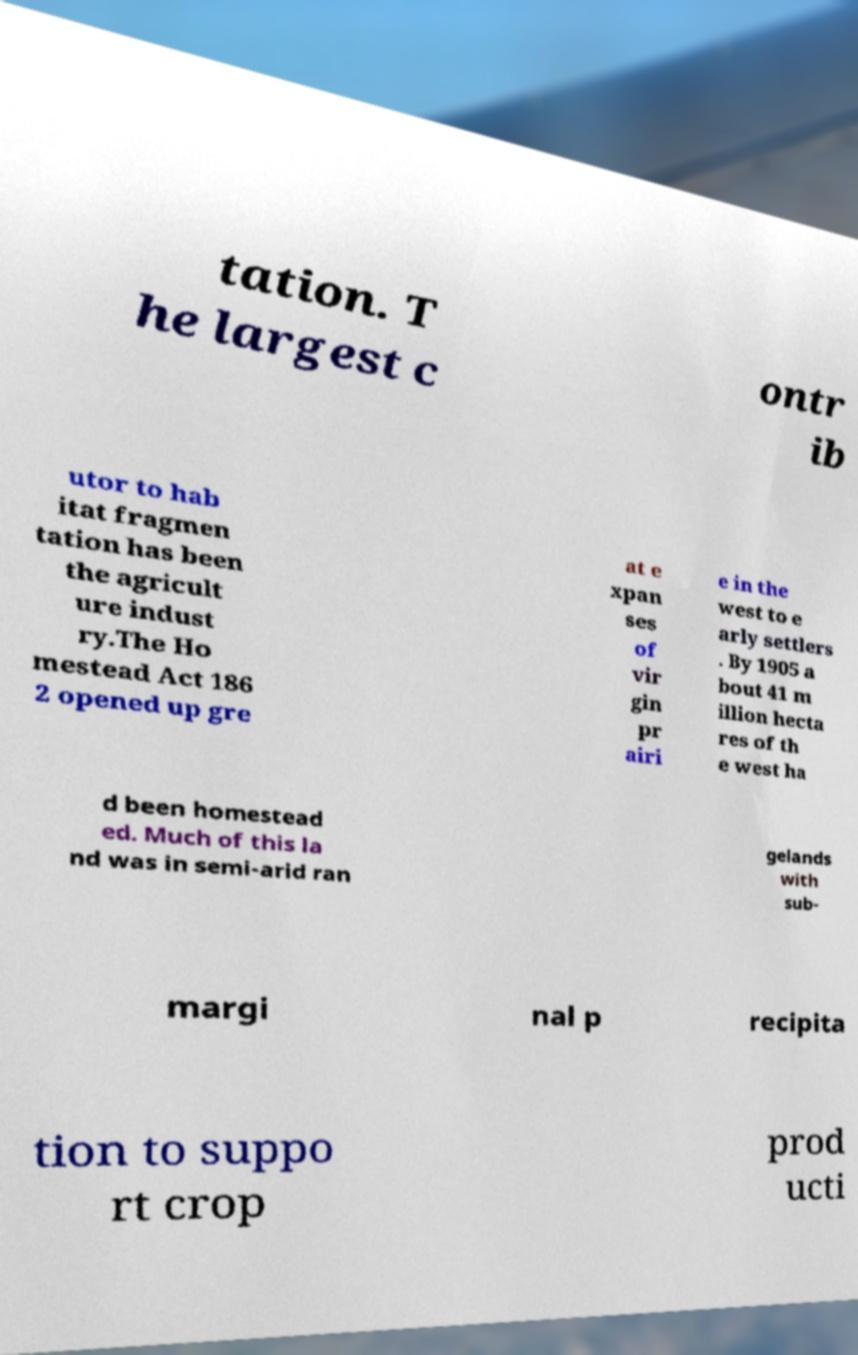Could you extract and type out the text from this image? tation. T he largest c ontr ib utor to hab itat fragmen tation has been the agricult ure indust ry.The Ho mestead Act 186 2 opened up gre at e xpan ses of vir gin pr airi e in the west to e arly settlers . By 1905 a bout 41 m illion hecta res of th e west ha d been homestead ed. Much of this la nd was in semi-arid ran gelands with sub- margi nal p recipita tion to suppo rt crop prod ucti 